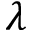<formula> <loc_0><loc_0><loc_500><loc_500>\lambda</formula> 